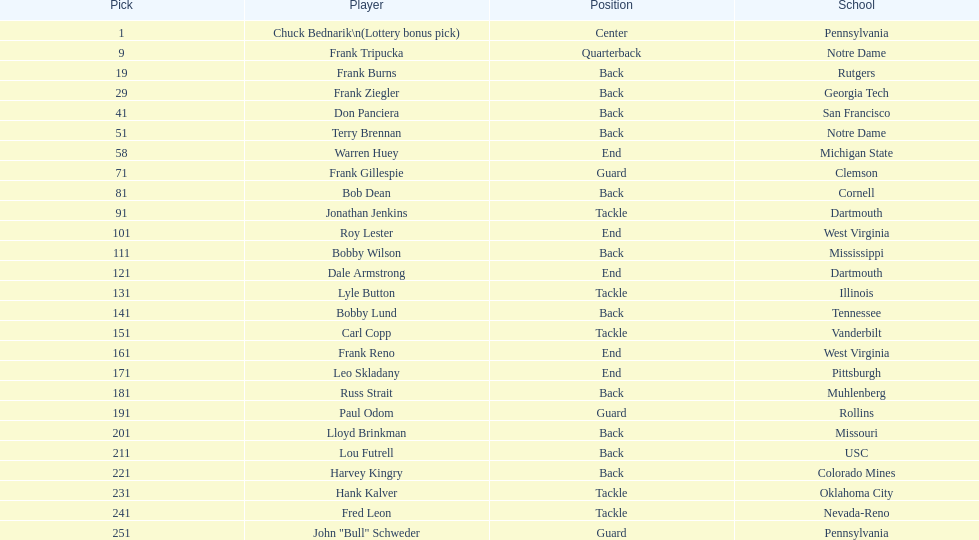What was the position that most of the players had? Back. 